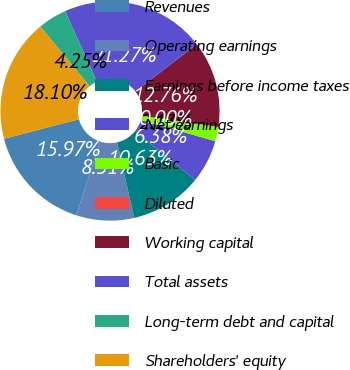Convert chart. <chart><loc_0><loc_0><loc_500><loc_500><pie_chart><fcel>Revenues<fcel>Operating earnings<fcel>Earnings before income taxes<fcel>Net earnings<fcel>Basic<fcel>Diluted<fcel>Working capital<fcel>Total assets<fcel>Long-term debt and capital<fcel>Shareholders' equity<nl><fcel>15.97%<fcel>8.51%<fcel>10.63%<fcel>6.38%<fcel>2.13%<fcel>0.0%<fcel>12.76%<fcel>21.27%<fcel>4.25%<fcel>18.1%<nl></chart> 